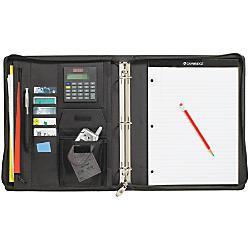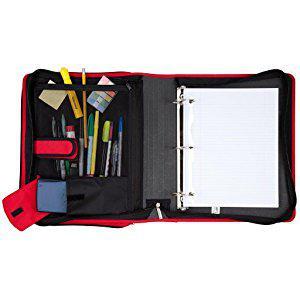The first image is the image on the left, the second image is the image on the right. Given the left and right images, does the statement "There are writing utensils inside a mesh compartment." hold true? Answer yes or no. Yes. The first image is the image on the left, the second image is the image on the right. Analyze the images presented: Is the assertion "Each image includes one open ring binder, and at least one of the binders pictured is filled with paper and other supplies." valid? Answer yes or no. Yes. 